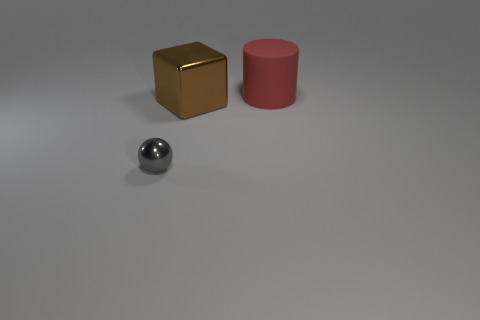There is a cylinder that is the same size as the block; what is it made of?
Give a very brief answer. Rubber. What number of other things are the same color as the big cylinder?
Provide a short and direct response. 0. What number of blue things are either shiny things or big rubber objects?
Offer a terse response. 0. What number of other objects are there of the same material as the brown thing?
Make the answer very short. 1. Are there any big blocks that are in front of the big object that is right of the shiny thing that is behind the tiny sphere?
Your answer should be very brief. Yes. Is the gray thing made of the same material as the red thing?
Offer a very short reply. No. Are there any other things that are the same shape as the big red rubber object?
Offer a very short reply. No. The gray ball that is in front of the big thing in front of the big rubber cylinder is made of what material?
Give a very brief answer. Metal. What size is the thing that is behind the big brown metal block?
Ensure brevity in your answer.  Large. What is the color of the object that is behind the metallic sphere and in front of the large red cylinder?
Ensure brevity in your answer.  Brown. 